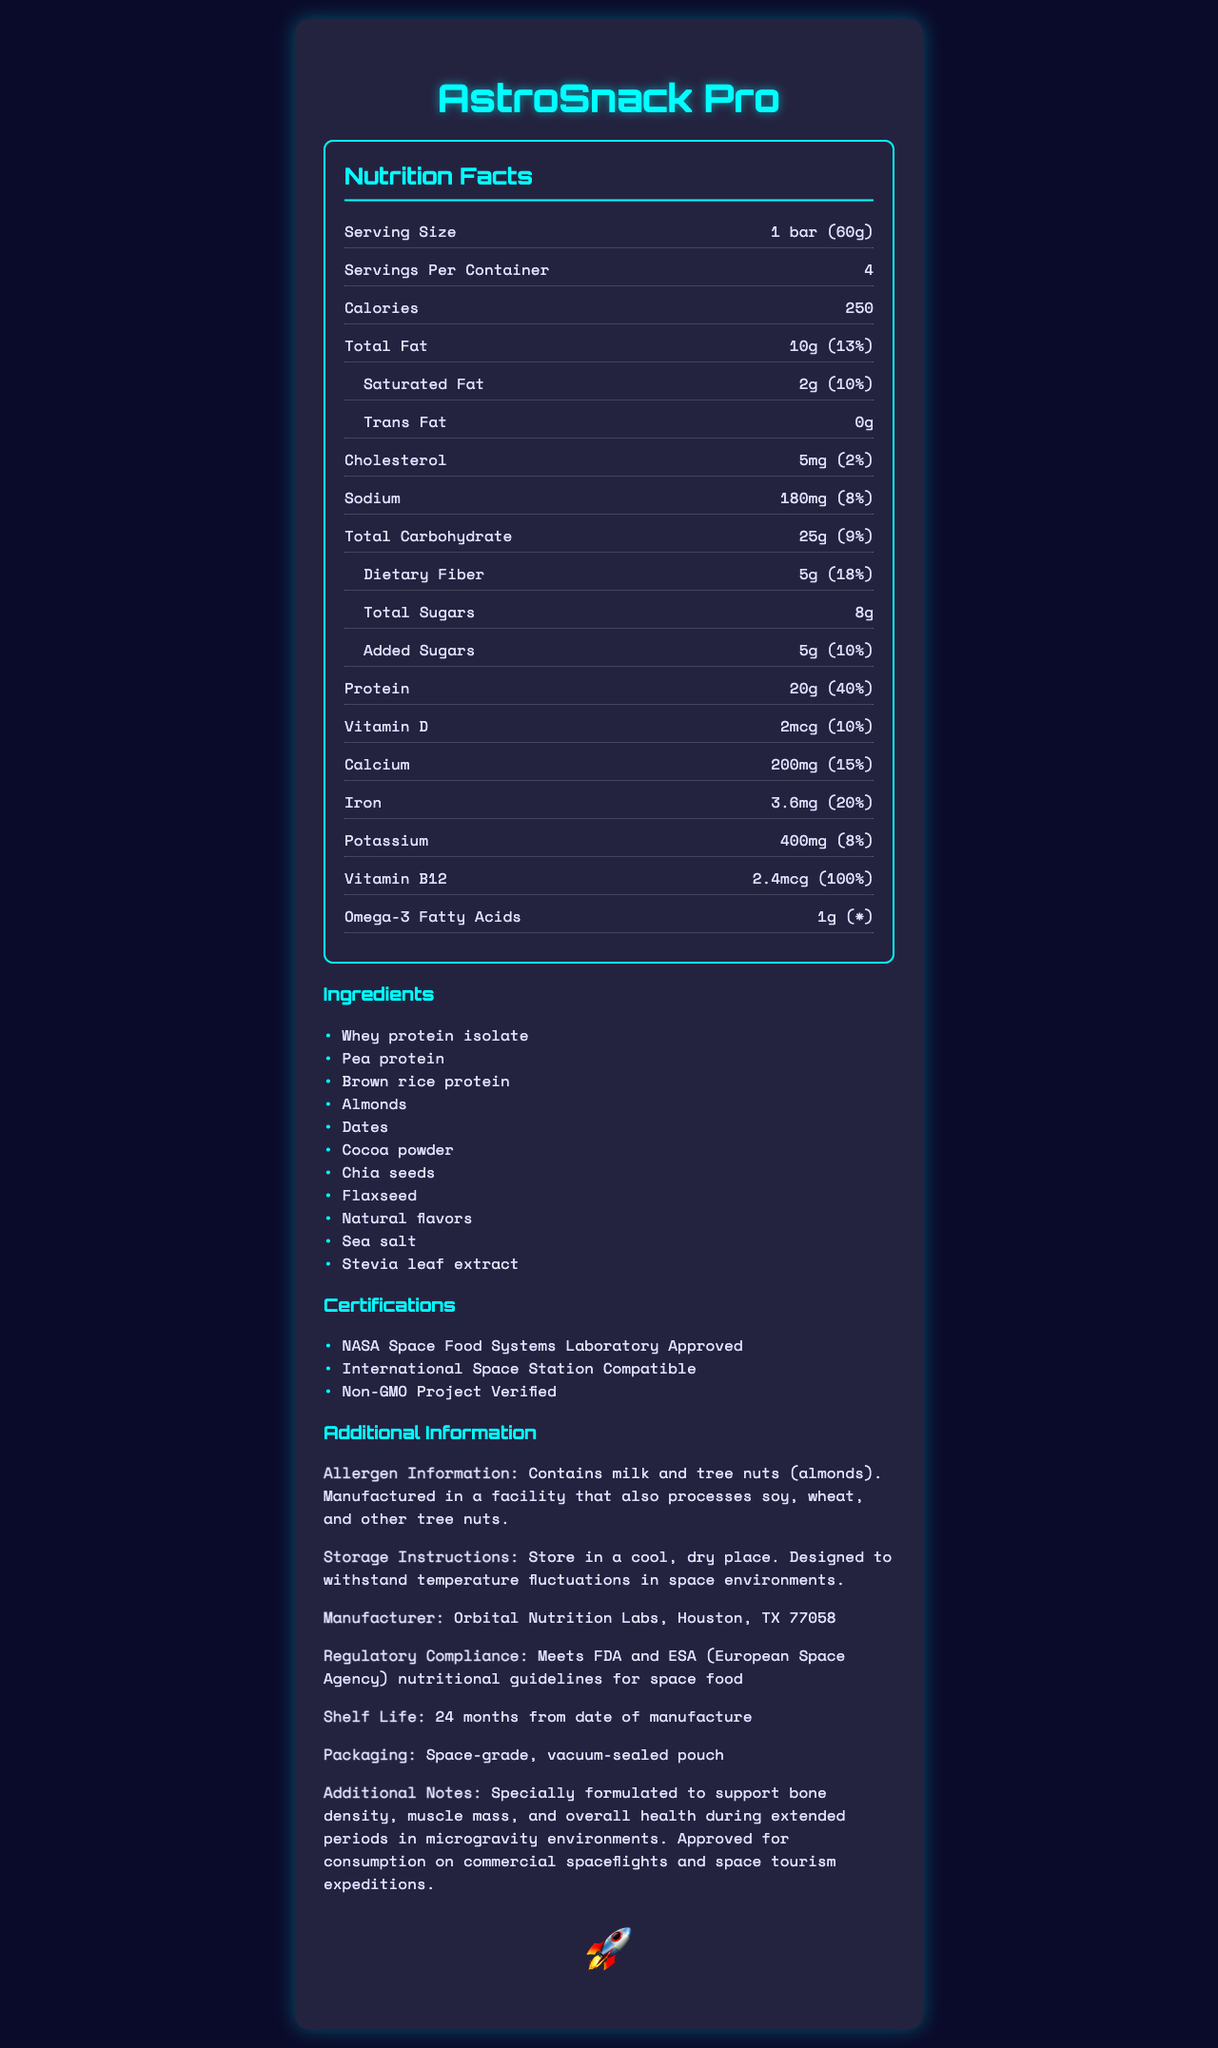What is the serving size of AstroSnack Pro? The serving size is clearly stated in the document as "1 bar (60g)".
Answer: 1 bar (60g) How many calories are there per serving of AstroSnack Pro? The document specifies that there are 250 calories per serving.
Answer: 250 calories Which ingredient in AstroSnack Pro is a source of protein? The ingredients list states "Whey protein isolate", "Pea protein", and "Brown rice protein" as sources of protein.
Answer: Whey protein isolate, Pea protein, Brown rice protein What is the total amount of carbohydrates per serving? The nutrition facts section lists "Total Carbohydrate" as 25g per serving.
Answer: 25g What is the shelf life of AstroSnack Pro? The document specifies the shelf life as "24 months from date of manufacture".
Answer: 24 months from date of manufacture Which certification ensures compatibility with space environments? A. USDA Organic B. International Space Station Compatible C. Kosher Certified The document includes several certifications, and "International Space Station Compatible" ensures compatibility with space environments.
Answer: B. International Space Station Compatible How much protein does one serving provide, and what percentage of the daily value does this represent? The nutrition facts section lists protein content as 20g, which is 40% of the daily value.
Answer: 20g, 40% Is Vitamin B12 present in AstroSnack Pro? The document lists Vitamin B12 with an amount of 2.4mcg and a daily value percentage of 100%.
Answer: Yes What is the main source of sweetness in AstroSnack Pro? A. Honey B. Dates C. Sugar The ingredients list includes "Dates" which is a natural source of sweetness.
Answer: B. Dates Can someone with a nut allergy safely consume AstroSnack Pro? The allergen information states that AstroSnack Pro contains tree nuts (almonds) and is manufactured in a facility that processes other nuts.
Answer: No What is the main purpose of AstroSnack Pro? The additional notes section explains that the snack is formulated for extended periods in microgravity environments.
Answer: To support bone density, muscle mass, and overall health during extended periods in microgravity environments Where is AstroSnack Pro manufactured? The manufacturer information states this location.
Answer: Orbital Nutrition Labs, Houston, TX 77058 What are the benefits mentioned for consuming AstroSnack Pro during space tourism expeditions? The additional notes list these benefits of consuming AstroSnack Pro during space tourism expeditions.
Answer: Supports bone density, muscle mass, overall health What is the packaging type for AstroSnack Pro? The document specifies the packaging as a space-grade, vacuum-sealed pouch.
Answer: Space-grade, vacuum-sealed pouch How should AstroSnack Pro be stored? The storage instructions specify this method.
Answer: Store in a cool, dry place. Designed to withstand temperature fluctuations in space environments. Does AstroSnack Pro contain any trans fat? The nutrition facts section states that there is 0g of trans fat.
Answer: No How does AstroSnack Pro comply with space food regulations? The document states compliance with FDA and ESA nutritional guidelines.
Answer: Meets FDA and ESA nutritional guidelines for space food How much Omega-3 fatty acids does each serving of AstroSnack Pro contain? The nutrition facts lists Omega-3 fatty acids as 1g per serving.
Answer: 1g Which certification indicates that AstroSnack Pro is non-GMO? The certifications section lists this certification.
Answer: Non-GMO Project Verified What additional notes are provided about the formulation of AstroSnack Pro? The additional notes section provides these details about the formulation.
Answer: Specially formulated to support bone density, muscle mass, and overall health during extended periods in microgravity environments. Approved for consumption on commercial spaceflights and space tourism expeditions. 